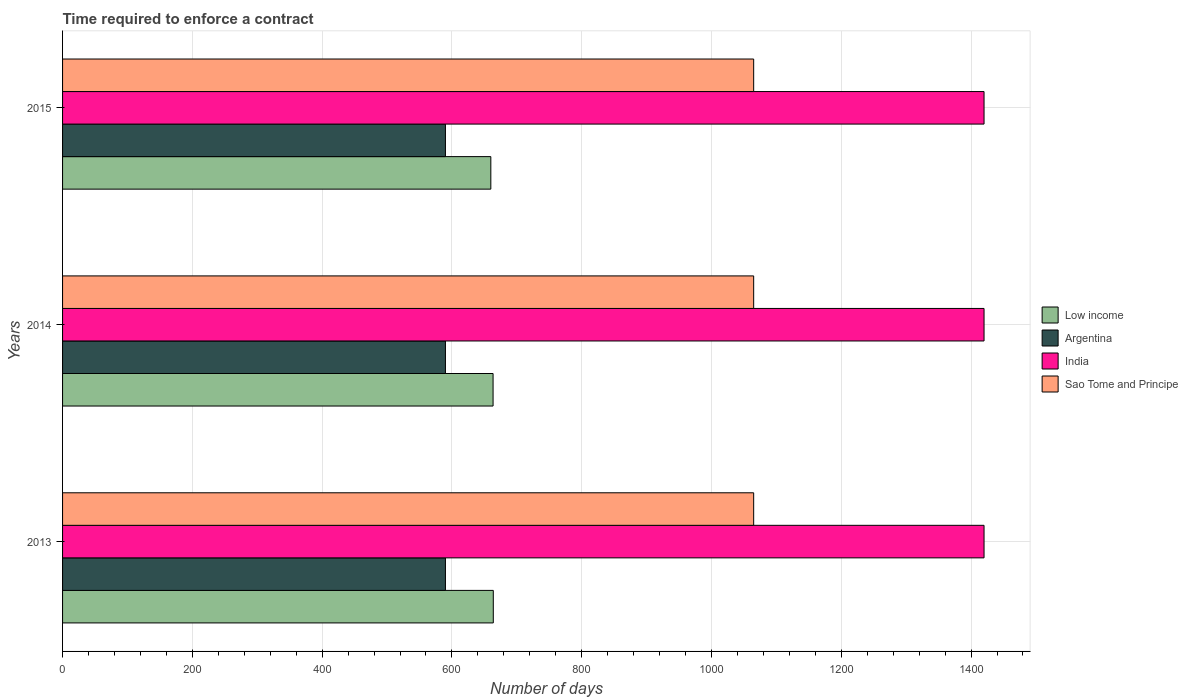How many groups of bars are there?
Give a very brief answer. 3. Are the number of bars on each tick of the Y-axis equal?
Provide a succinct answer. Yes. In how many cases, is the number of bars for a given year not equal to the number of legend labels?
Provide a short and direct response. 0. What is the number of days required to enforce a contract in Sao Tome and Principe in 2015?
Keep it short and to the point. 1065. Across all years, what is the maximum number of days required to enforce a contract in Sao Tome and Principe?
Provide a succinct answer. 1065. Across all years, what is the minimum number of days required to enforce a contract in Argentina?
Your response must be concise. 590. In which year was the number of days required to enforce a contract in Low income minimum?
Your answer should be compact. 2015. What is the total number of days required to enforce a contract in Argentina in the graph?
Offer a terse response. 1770. What is the difference between the number of days required to enforce a contract in Argentina in 2013 and the number of days required to enforce a contract in India in 2015?
Provide a short and direct response. -830. What is the average number of days required to enforce a contract in Argentina per year?
Your answer should be compact. 590. In the year 2015, what is the difference between the number of days required to enforce a contract in Low income and number of days required to enforce a contract in Argentina?
Make the answer very short. 69.97. What is the ratio of the number of days required to enforce a contract in Argentina in 2013 to that in 2015?
Provide a short and direct response. 1. Is the number of days required to enforce a contract in Low income in 2013 less than that in 2015?
Make the answer very short. No. Is the difference between the number of days required to enforce a contract in Low income in 2013 and 2015 greater than the difference between the number of days required to enforce a contract in Argentina in 2013 and 2015?
Keep it short and to the point. Yes. What is the difference between the highest and the second highest number of days required to enforce a contract in Low income?
Your response must be concise. 0.34. What is the difference between the highest and the lowest number of days required to enforce a contract in Low income?
Give a very brief answer. 3.79. What does the 4th bar from the bottom in 2015 represents?
Your answer should be compact. Sao Tome and Principe. How many years are there in the graph?
Your answer should be compact. 3. What is the difference between two consecutive major ticks on the X-axis?
Provide a succinct answer. 200. Does the graph contain grids?
Offer a terse response. Yes. Where does the legend appear in the graph?
Make the answer very short. Center right. How are the legend labels stacked?
Ensure brevity in your answer.  Vertical. What is the title of the graph?
Keep it short and to the point. Time required to enforce a contract. What is the label or title of the X-axis?
Offer a very short reply. Number of days. What is the Number of days of Low income in 2013?
Offer a terse response. 663.76. What is the Number of days of Argentina in 2013?
Your answer should be compact. 590. What is the Number of days of India in 2013?
Offer a terse response. 1420. What is the Number of days of Sao Tome and Principe in 2013?
Your response must be concise. 1065. What is the Number of days of Low income in 2014?
Give a very brief answer. 663.41. What is the Number of days of Argentina in 2014?
Offer a very short reply. 590. What is the Number of days of India in 2014?
Your answer should be very brief. 1420. What is the Number of days in Sao Tome and Principe in 2014?
Provide a short and direct response. 1065. What is the Number of days of Low income in 2015?
Your answer should be very brief. 659.97. What is the Number of days of Argentina in 2015?
Give a very brief answer. 590. What is the Number of days in India in 2015?
Your answer should be very brief. 1420. What is the Number of days in Sao Tome and Principe in 2015?
Provide a succinct answer. 1065. Across all years, what is the maximum Number of days in Low income?
Your answer should be compact. 663.76. Across all years, what is the maximum Number of days of Argentina?
Your answer should be very brief. 590. Across all years, what is the maximum Number of days of India?
Your answer should be very brief. 1420. Across all years, what is the maximum Number of days in Sao Tome and Principe?
Your answer should be very brief. 1065. Across all years, what is the minimum Number of days in Low income?
Your answer should be compact. 659.97. Across all years, what is the minimum Number of days in Argentina?
Provide a succinct answer. 590. Across all years, what is the minimum Number of days of India?
Your response must be concise. 1420. Across all years, what is the minimum Number of days in Sao Tome and Principe?
Offer a very short reply. 1065. What is the total Number of days in Low income in the graph?
Your response must be concise. 1987.14. What is the total Number of days of Argentina in the graph?
Your response must be concise. 1770. What is the total Number of days in India in the graph?
Keep it short and to the point. 4260. What is the total Number of days of Sao Tome and Principe in the graph?
Your answer should be very brief. 3195. What is the difference between the Number of days of Low income in 2013 and that in 2014?
Offer a very short reply. 0.34. What is the difference between the Number of days in Argentina in 2013 and that in 2014?
Offer a very short reply. 0. What is the difference between the Number of days in India in 2013 and that in 2014?
Your answer should be very brief. 0. What is the difference between the Number of days in Low income in 2013 and that in 2015?
Keep it short and to the point. 3.79. What is the difference between the Number of days in Argentina in 2013 and that in 2015?
Provide a succinct answer. 0. What is the difference between the Number of days of India in 2013 and that in 2015?
Give a very brief answer. 0. What is the difference between the Number of days in Sao Tome and Principe in 2013 and that in 2015?
Provide a succinct answer. 0. What is the difference between the Number of days in Low income in 2014 and that in 2015?
Your answer should be compact. 3.45. What is the difference between the Number of days of India in 2014 and that in 2015?
Your response must be concise. 0. What is the difference between the Number of days of Low income in 2013 and the Number of days of Argentina in 2014?
Your response must be concise. 73.76. What is the difference between the Number of days in Low income in 2013 and the Number of days in India in 2014?
Provide a short and direct response. -756.24. What is the difference between the Number of days of Low income in 2013 and the Number of days of Sao Tome and Principe in 2014?
Your answer should be very brief. -401.24. What is the difference between the Number of days of Argentina in 2013 and the Number of days of India in 2014?
Offer a very short reply. -830. What is the difference between the Number of days in Argentina in 2013 and the Number of days in Sao Tome and Principe in 2014?
Make the answer very short. -475. What is the difference between the Number of days in India in 2013 and the Number of days in Sao Tome and Principe in 2014?
Give a very brief answer. 355. What is the difference between the Number of days in Low income in 2013 and the Number of days in Argentina in 2015?
Your response must be concise. 73.76. What is the difference between the Number of days of Low income in 2013 and the Number of days of India in 2015?
Provide a short and direct response. -756.24. What is the difference between the Number of days of Low income in 2013 and the Number of days of Sao Tome and Principe in 2015?
Offer a very short reply. -401.24. What is the difference between the Number of days of Argentina in 2013 and the Number of days of India in 2015?
Your answer should be very brief. -830. What is the difference between the Number of days of Argentina in 2013 and the Number of days of Sao Tome and Principe in 2015?
Keep it short and to the point. -475. What is the difference between the Number of days of India in 2013 and the Number of days of Sao Tome and Principe in 2015?
Your response must be concise. 355. What is the difference between the Number of days in Low income in 2014 and the Number of days in Argentina in 2015?
Ensure brevity in your answer.  73.41. What is the difference between the Number of days in Low income in 2014 and the Number of days in India in 2015?
Make the answer very short. -756.59. What is the difference between the Number of days of Low income in 2014 and the Number of days of Sao Tome and Principe in 2015?
Offer a terse response. -401.59. What is the difference between the Number of days of Argentina in 2014 and the Number of days of India in 2015?
Your answer should be very brief. -830. What is the difference between the Number of days of Argentina in 2014 and the Number of days of Sao Tome and Principe in 2015?
Offer a very short reply. -475. What is the difference between the Number of days in India in 2014 and the Number of days in Sao Tome and Principe in 2015?
Provide a short and direct response. 355. What is the average Number of days of Low income per year?
Your answer should be compact. 662.38. What is the average Number of days in Argentina per year?
Your answer should be very brief. 590. What is the average Number of days of India per year?
Give a very brief answer. 1420. What is the average Number of days in Sao Tome and Principe per year?
Give a very brief answer. 1065. In the year 2013, what is the difference between the Number of days of Low income and Number of days of Argentina?
Keep it short and to the point. 73.76. In the year 2013, what is the difference between the Number of days in Low income and Number of days in India?
Make the answer very short. -756.24. In the year 2013, what is the difference between the Number of days of Low income and Number of days of Sao Tome and Principe?
Ensure brevity in your answer.  -401.24. In the year 2013, what is the difference between the Number of days in Argentina and Number of days in India?
Give a very brief answer. -830. In the year 2013, what is the difference between the Number of days in Argentina and Number of days in Sao Tome and Principe?
Your answer should be compact. -475. In the year 2013, what is the difference between the Number of days in India and Number of days in Sao Tome and Principe?
Offer a terse response. 355. In the year 2014, what is the difference between the Number of days of Low income and Number of days of Argentina?
Your response must be concise. 73.41. In the year 2014, what is the difference between the Number of days in Low income and Number of days in India?
Your response must be concise. -756.59. In the year 2014, what is the difference between the Number of days in Low income and Number of days in Sao Tome and Principe?
Make the answer very short. -401.59. In the year 2014, what is the difference between the Number of days of Argentina and Number of days of India?
Give a very brief answer. -830. In the year 2014, what is the difference between the Number of days in Argentina and Number of days in Sao Tome and Principe?
Provide a short and direct response. -475. In the year 2014, what is the difference between the Number of days in India and Number of days in Sao Tome and Principe?
Your response must be concise. 355. In the year 2015, what is the difference between the Number of days in Low income and Number of days in Argentina?
Give a very brief answer. 69.97. In the year 2015, what is the difference between the Number of days of Low income and Number of days of India?
Offer a very short reply. -760.03. In the year 2015, what is the difference between the Number of days in Low income and Number of days in Sao Tome and Principe?
Your answer should be very brief. -405.03. In the year 2015, what is the difference between the Number of days of Argentina and Number of days of India?
Make the answer very short. -830. In the year 2015, what is the difference between the Number of days in Argentina and Number of days in Sao Tome and Principe?
Your answer should be very brief. -475. In the year 2015, what is the difference between the Number of days of India and Number of days of Sao Tome and Principe?
Offer a terse response. 355. What is the ratio of the Number of days in Low income in 2013 to that in 2014?
Your answer should be very brief. 1. What is the ratio of the Number of days of Argentina in 2013 to that in 2014?
Your response must be concise. 1. What is the ratio of the Number of days in India in 2013 to that in 2014?
Make the answer very short. 1. What is the ratio of the Number of days in Sao Tome and Principe in 2013 to that in 2015?
Your answer should be very brief. 1. What is the difference between the highest and the second highest Number of days of Low income?
Offer a very short reply. 0.34. What is the difference between the highest and the second highest Number of days of Argentina?
Your answer should be very brief. 0. What is the difference between the highest and the second highest Number of days in India?
Offer a terse response. 0. What is the difference between the highest and the second highest Number of days of Sao Tome and Principe?
Your response must be concise. 0. What is the difference between the highest and the lowest Number of days in Low income?
Your response must be concise. 3.79. What is the difference between the highest and the lowest Number of days in Argentina?
Make the answer very short. 0. What is the difference between the highest and the lowest Number of days in India?
Offer a very short reply. 0. What is the difference between the highest and the lowest Number of days of Sao Tome and Principe?
Offer a terse response. 0. 